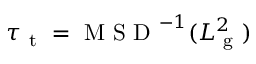Convert formula to latex. <formula><loc_0><loc_0><loc_500><loc_500>\tau _ { t } = M S D ^ { - 1 } ( L _ { g } ^ { 2 } )</formula> 